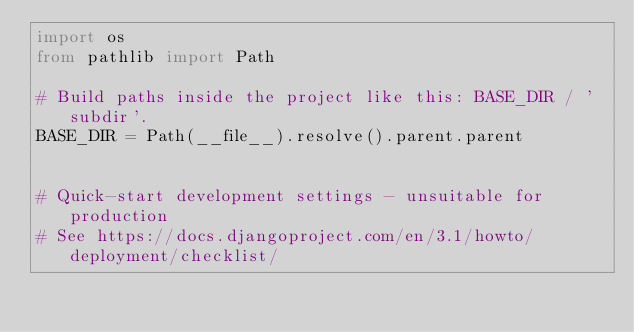Convert code to text. <code><loc_0><loc_0><loc_500><loc_500><_Python_>import os
from pathlib import Path

# Build paths inside the project like this: BASE_DIR / 'subdir'.
BASE_DIR = Path(__file__).resolve().parent.parent


# Quick-start development settings - unsuitable for production
# See https://docs.djangoproject.com/en/3.1/howto/deployment/checklist/
</code> 